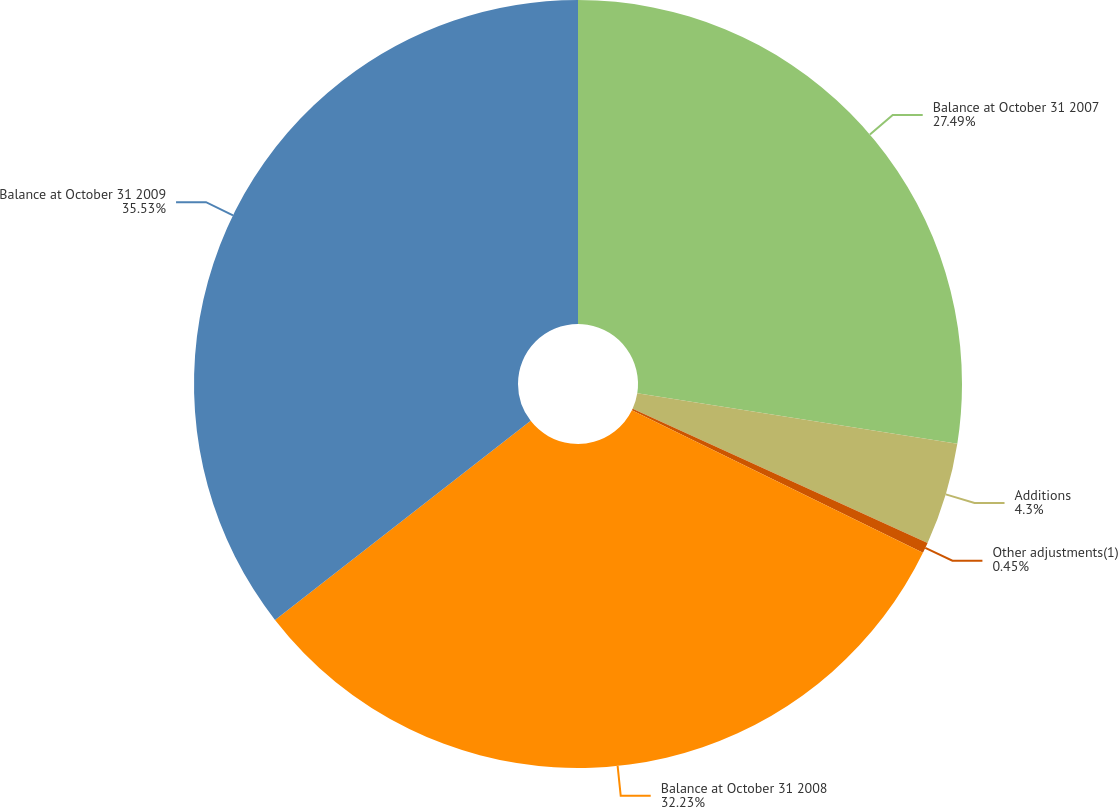<chart> <loc_0><loc_0><loc_500><loc_500><pie_chart><fcel>Balance at October 31 2007<fcel>Additions<fcel>Other adjustments(1)<fcel>Balance at October 31 2008<fcel>Balance at October 31 2009<nl><fcel>27.49%<fcel>4.3%<fcel>0.45%<fcel>32.23%<fcel>35.53%<nl></chart> 